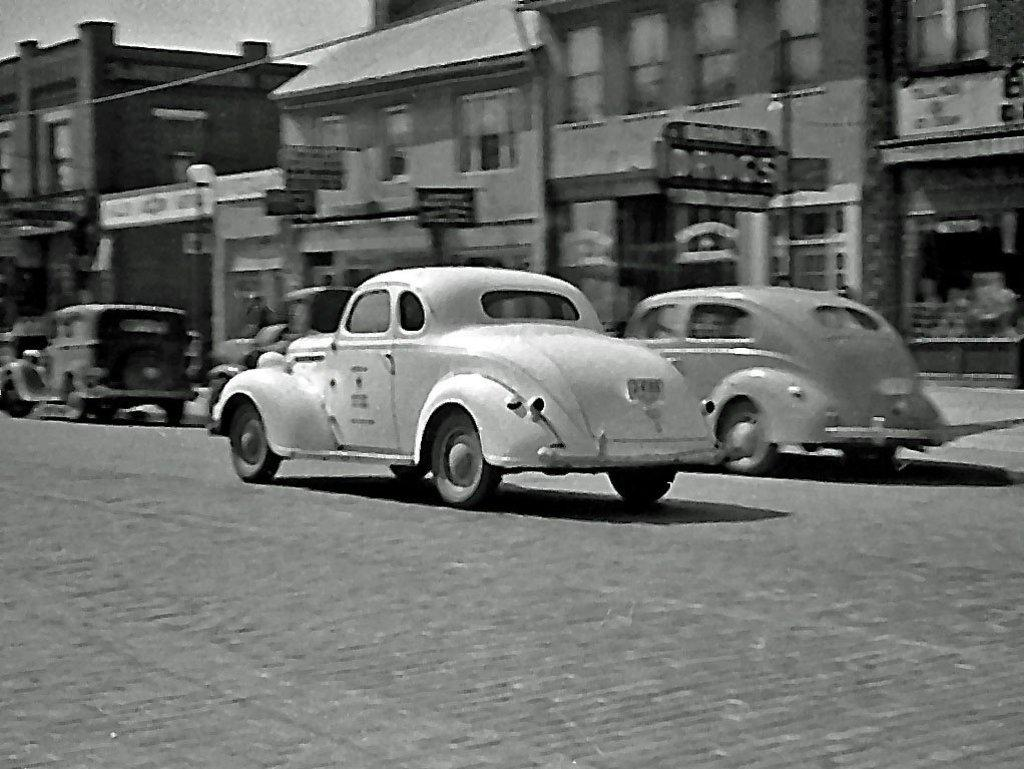What is the color scheme of the image? The image is black and white. What can be seen on the road in the image? There are cars on a road in the image. What type of structures are visible in the background of the image? There are buildings in the background of the image. What type of metal is the government using to build the cars in the image? There is no mention of metal or government in the image, and the image is in black and white, so it is not possible to determine the type of metal used in the cars. 